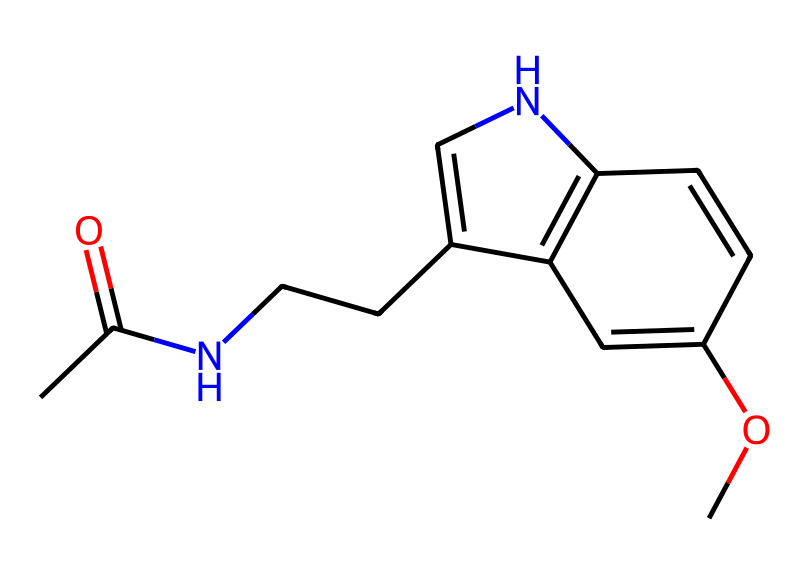What is the molecular formula of this compound? To determine the molecular formula, we need to count the carbon (C), hydrogen (H), nitrogen (N), and oxygen (O) atoms in the SMILES representation. The breakdown shows: 13 carbon atoms, 16 hydrogen atoms, 2 nitrogen atoms, and 1 oxygen atom. Thus, the molecular formula is C13H16N2O.
Answer: C13H16N2O How many rings are present in the structure? The structure can be analyzed for cyclic components. By examining the SMILES, two ring structures are evident due to the 'c' and '1' indicators in the notation, signifying two cyclic parts. The total number of rings is 2.
Answer: 2 What functional groups are present in melatonin? The SMILES representation includes several functional groups. The structure has an amide group (CC(=O)N), an ether group (OC), and potentially a nitrogen-containing ring. Thus, the functional groups present are amide and ether.
Answer: amide, ether Which atom in this compound is likely responsible for its biological activity? The nitrogen atoms in the structure, especially within the indole ring (which is key for biological activity in hormones), play a significant role in melatonin's function. They are critical for binding to receptors and affecting sleep regulation.
Answer: nitrogen What is the total number of hydrogen atoms in this molecule? To find the total number of hydrogen atoms, we observe the hydrogen atoms listed alongside other atoms in the SMILES representation. The count reveals a total of 16 hydrogen atoms in the molecular structure.
Answer: 16 What type of chemical is melatonin classified as? Melatonin is a hormone produced by the pineal gland that primarily regulates sleep-wake cycles. It is classified as a biogenic amine due to its structure and function in biological systems, specifically relating to neurotransmitter activity.
Answer: biogenic amine 